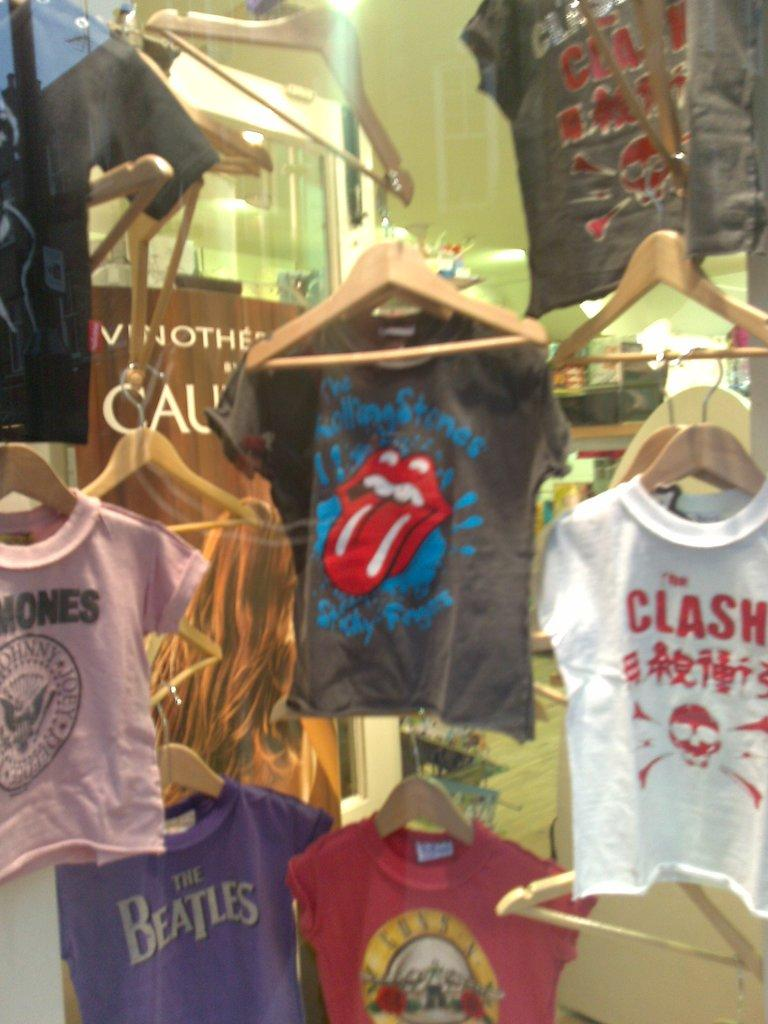What is hanging on the hangers in the image? Clothes are hanging on hangers in the image. Can you describe any other objects visible in the background of the image? Unfortunately, the provided facts do not give any information about the objects visible in the background. What type of chalk is being used to draw on the clothes in the image? There is no chalk or drawing present in the image; it only shows clothes hanging on hangers. 